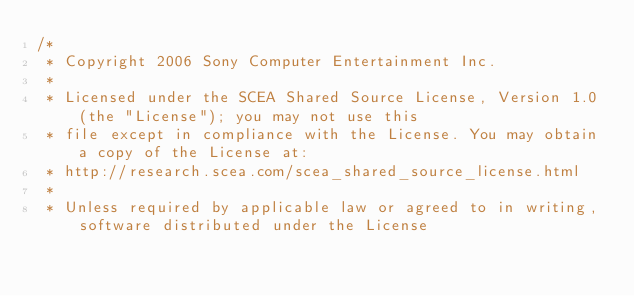Convert code to text. <code><loc_0><loc_0><loc_500><loc_500><_C++_>/*
 * Copyright 2006 Sony Computer Entertainment Inc.
 *
 * Licensed under the SCEA Shared Source License, Version 1.0 (the "License"); you may not use this 
 * file except in compliance with the License. You may obtain a copy of the License at:
 * http://research.scea.com/scea_shared_source_license.html
 *
 * Unless required by applicable law or agreed to in writing, software distributed under the License </code> 